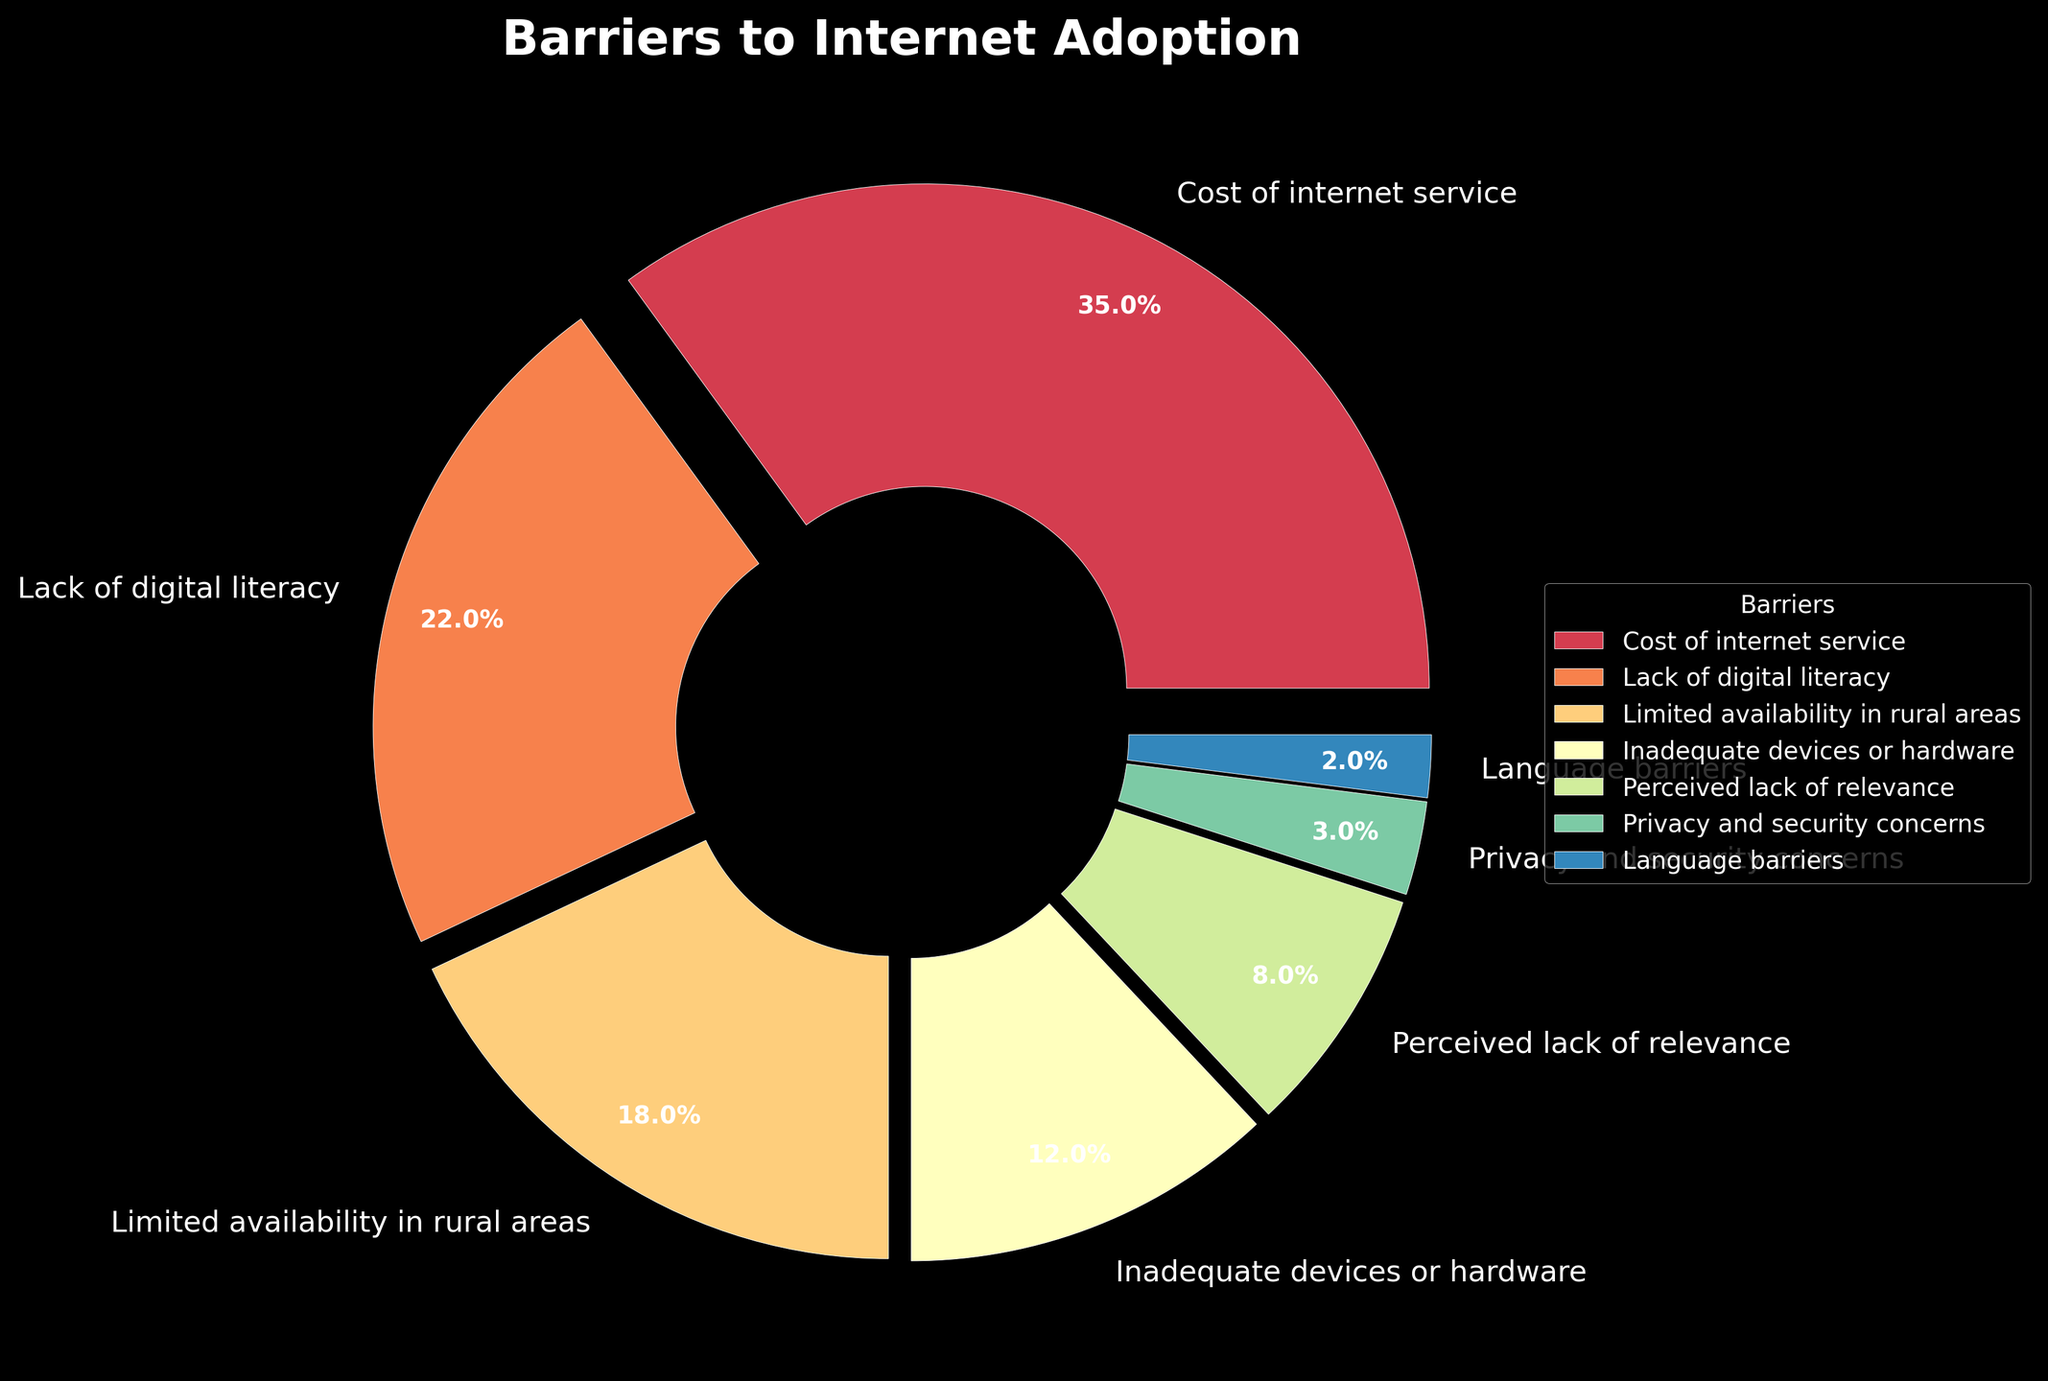What's the largest barrier to internet adoption according to the figure? The largest barrier can be determined by finding the label with the highest percentage. The figure shows that "Cost of internet service" has the highest percentage.
Answer: Cost of internet service What is the total percentage of barriers related to access issues (cost and availability)? To find the total percentage of barriers related to access issues, sum the percentages of "Cost of internet service" and "Limited availability in rural areas" (35% + 18%).
Answer: 53% How does the percentage of people facing digital literacy issues compare to those facing device inadequacy? Compare the percentages of "Lack of digital literacy" (22%) and "Inadequate devices or hardware" (12%). The figure shows that the percentage of people facing digital literacy issues is higher.
Answer: Digital literacy issues are higher What is the combined percentage for privacy/security and language barriers? Add the percentages of "Privacy and security concerns" (3%) and "Language barriers" (2%) to find the combined percentage.
Answer: 5% Which barrier is represented by the smallest wedge in the pie chart? Identify the smallest wedge by comparing the percentages. The figure shows that "Language barriers" has the smallest percentage at 2%.
Answer: Language barriers Is the percentage of people facing perceived lack of relevance greater than those facing privacy and security concerns? Compare the percentages of "Perceived lack of relevance" (8%) and "Privacy and security concerns" (3%). The figure shows that "Perceived lack of relevance" is greater.
Answer: Yes Which color is associated with the "Lack of digital literacy" segment in the pie chart? Find the segment labeled "Lack of digital literacy" in the chart and describe the color. The figure indicates it is a moderate shade between the darkest and the lightest colors used.
Answer: A moderate shade (specific color not detailed) What's the sum of percentages for digital literacy issues and perceived lack of relevance? Add the percentages of "Lack of digital literacy" (22%) and "Perceived lack of relevance" (8%) to get the total.
Answer: 30% What proportion of the chart is dedicated to barriers other than cost? Subtract the percentage of "Cost of internet service" (35%) from 100% to find the proportion of the chart representing other barriers.
Answer: 65% How much larger is the cost barrier compared to the privacy concern barrier? Subtract the percentage of "Privacy and security concerns" (3%) from "Cost of internet service" (35%) to determine the difference.
Answer: 32% 